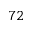<formula> <loc_0><loc_0><loc_500><loc_500>7 2</formula> 